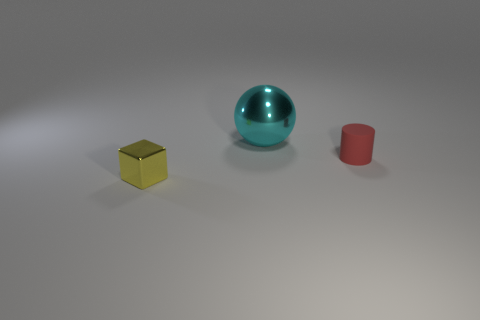Subtract all gray cylinders. Subtract all yellow cubes. How many cylinders are left? 1 Add 2 large cyan things. How many objects exist? 5 Subtract all cylinders. How many objects are left? 2 Add 2 small yellow metal things. How many small yellow metal things are left? 3 Add 1 metallic cubes. How many metallic cubes exist? 2 Subtract 0 blue cubes. How many objects are left? 3 Subtract all small yellow things. Subtract all red things. How many objects are left? 1 